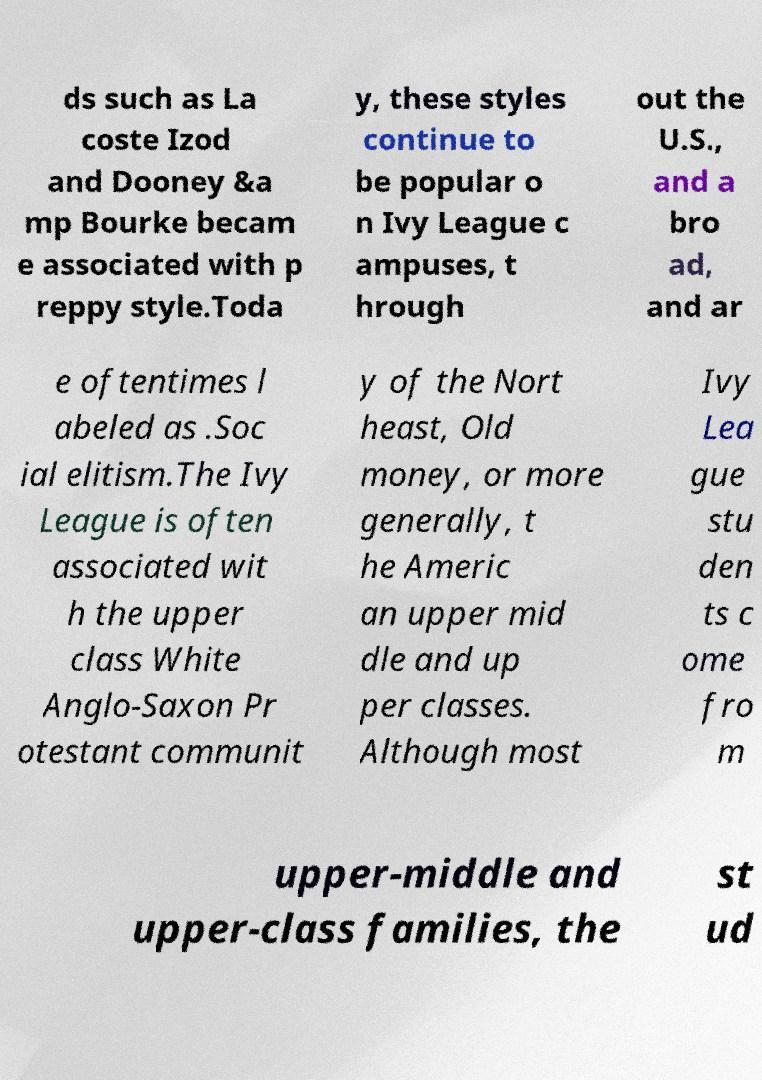Can you read and provide the text displayed in the image?This photo seems to have some interesting text. Can you extract and type it out for me? ds such as La coste Izod and Dooney &a mp Bourke becam e associated with p reppy style.Toda y, these styles continue to be popular o n Ivy League c ampuses, t hrough out the U.S., and a bro ad, and ar e oftentimes l abeled as .Soc ial elitism.The Ivy League is often associated wit h the upper class White Anglo-Saxon Pr otestant communit y of the Nort heast, Old money, or more generally, t he Americ an upper mid dle and up per classes. Although most Ivy Lea gue stu den ts c ome fro m upper-middle and upper-class families, the st ud 